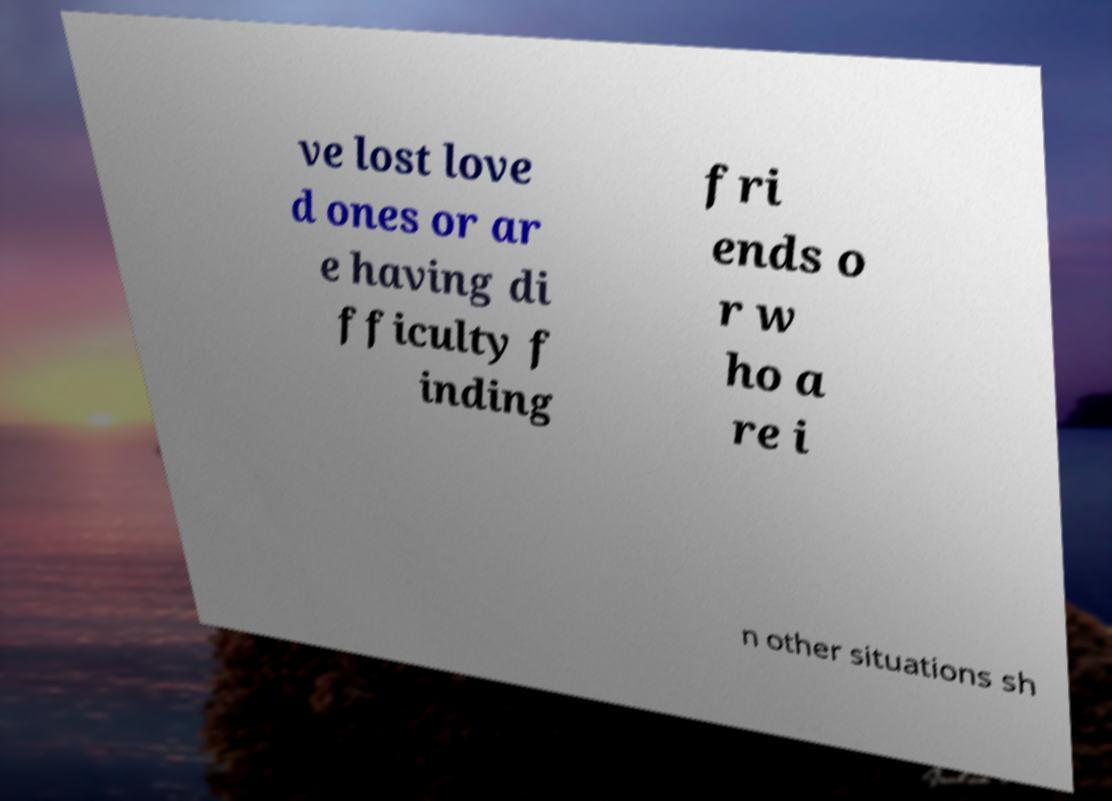Please identify and transcribe the text found in this image. ve lost love d ones or ar e having di fficulty f inding fri ends o r w ho a re i n other situations sh 